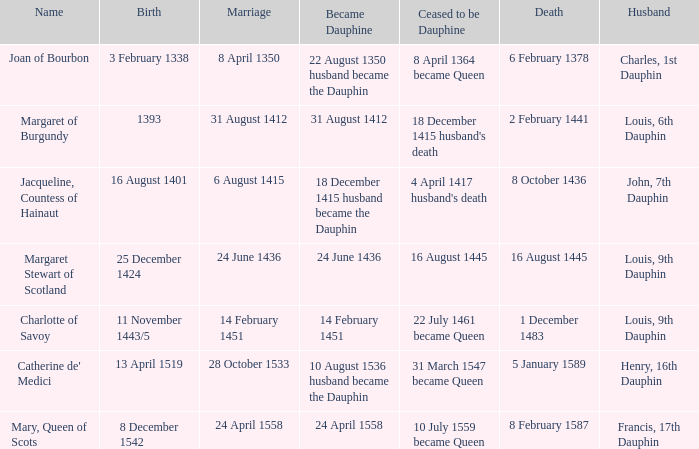Who has a birth of 16 august 1401? Jacqueline, Countess of Hainaut. 